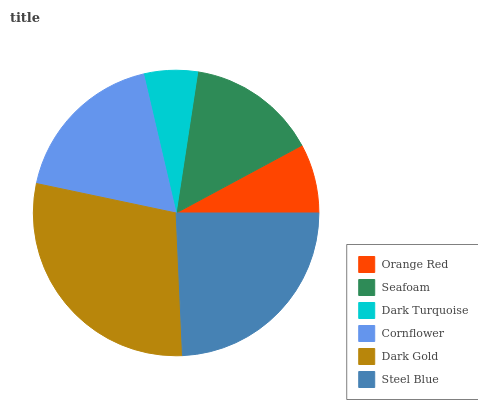Is Dark Turquoise the minimum?
Answer yes or no. Yes. Is Dark Gold the maximum?
Answer yes or no. Yes. Is Seafoam the minimum?
Answer yes or no. No. Is Seafoam the maximum?
Answer yes or no. No. Is Seafoam greater than Orange Red?
Answer yes or no. Yes. Is Orange Red less than Seafoam?
Answer yes or no. Yes. Is Orange Red greater than Seafoam?
Answer yes or no. No. Is Seafoam less than Orange Red?
Answer yes or no. No. Is Cornflower the high median?
Answer yes or no. Yes. Is Seafoam the low median?
Answer yes or no. Yes. Is Dark Turquoise the high median?
Answer yes or no. No. Is Dark Gold the low median?
Answer yes or no. No. 